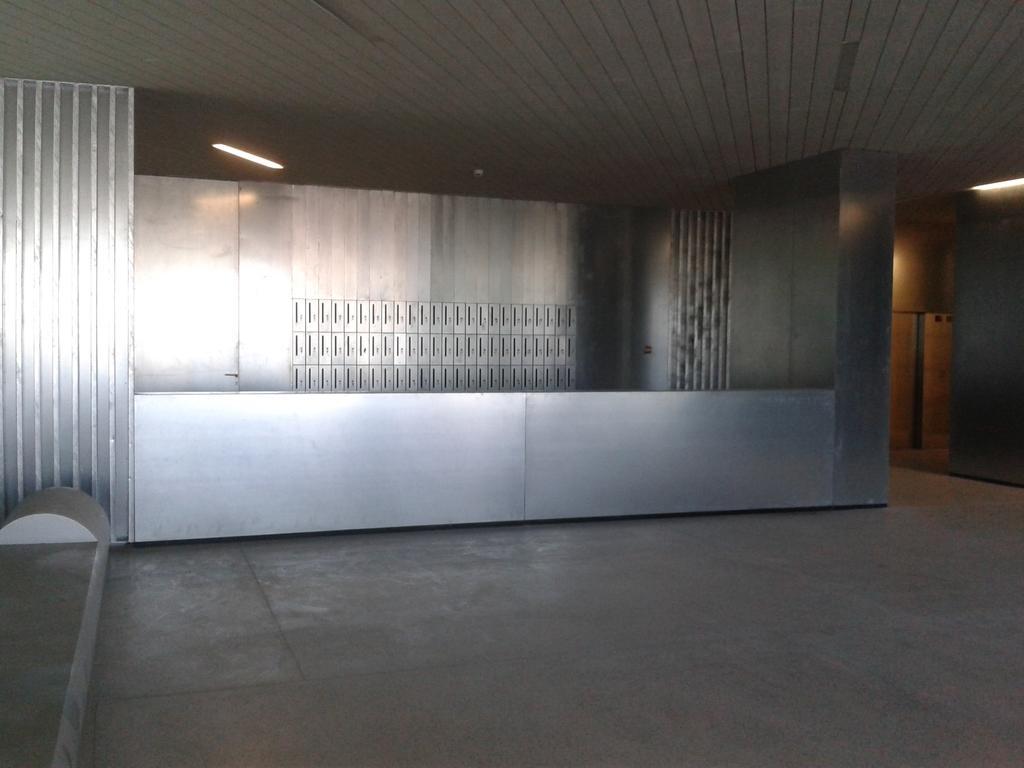Please provide a concise description of this image. In this image I can see the inner part of the building. I can see the steel object, background I can see few lights. 